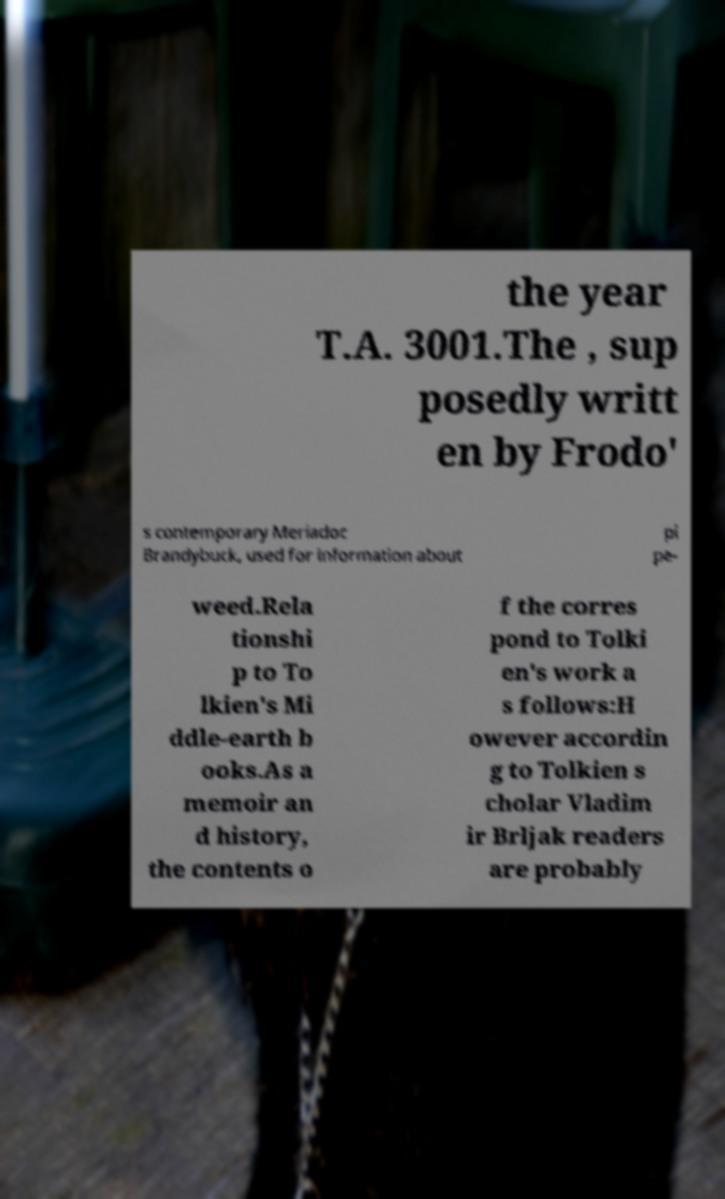I need the written content from this picture converted into text. Can you do that? the year T.A. 3001.The , sup posedly writt en by Frodo' s contemporary Meriadoc Brandybuck, used for information about pi pe- weed.Rela tionshi p to To lkien's Mi ddle-earth b ooks.As a memoir an d history, the contents o f the corres pond to Tolki en's work a s follows:H owever accordin g to Tolkien s cholar Vladim ir Brljak readers are probably 